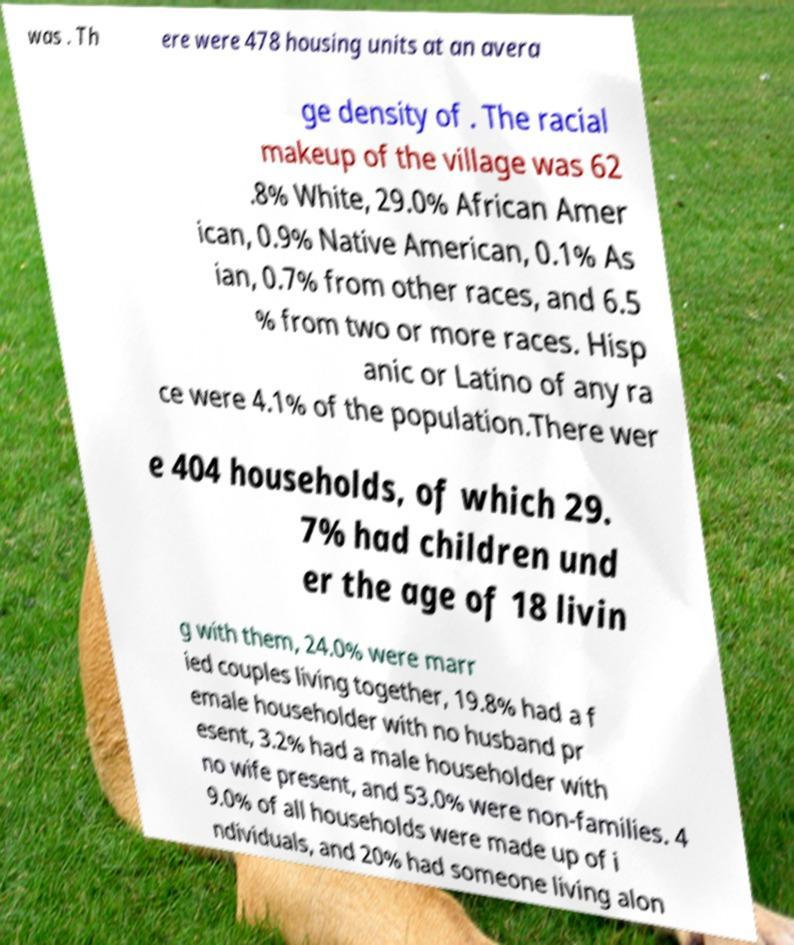Could you assist in decoding the text presented in this image and type it out clearly? was . Th ere were 478 housing units at an avera ge density of . The racial makeup of the village was 62 .8% White, 29.0% African Amer ican, 0.9% Native American, 0.1% As ian, 0.7% from other races, and 6.5 % from two or more races. Hisp anic or Latino of any ra ce were 4.1% of the population.There wer e 404 households, of which 29. 7% had children und er the age of 18 livin g with them, 24.0% were marr ied couples living together, 19.8% had a f emale householder with no husband pr esent, 3.2% had a male householder with no wife present, and 53.0% were non-families. 4 9.0% of all households were made up of i ndividuals, and 20% had someone living alon 